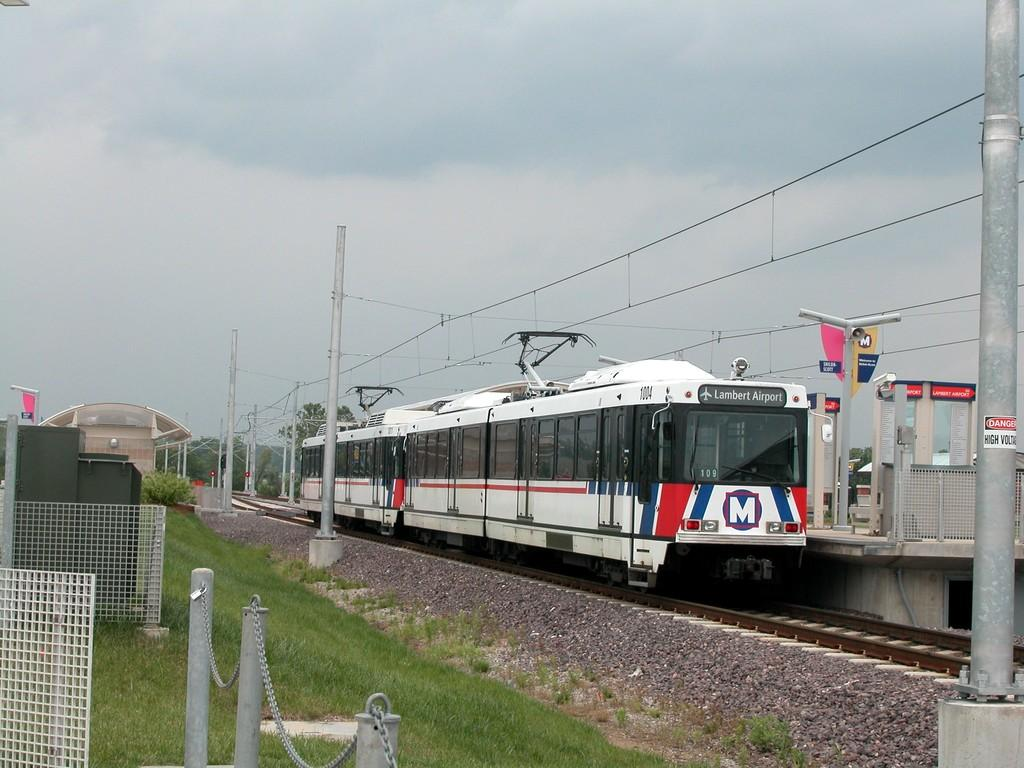What is the main subject of the image? The main subject of the image is a train. Where is the train located in the image? The train is on a train track. What can be seen in the background of the image? Electric poles and electric wires are visible in the image. What type of surface is present near the train? There is a mesh, grass, and stones in the image. How would you describe the weather in the image? The sky is cloudy in the image. Can you tell me how many times the river is mentioned in the image? There is no river present in the image, so it cannot be mentioned. What type of chain can be seen connecting the train to the electric poles in the image? There is no chain connecting the train to the electric poles in the image; the train is on a train track, and the electric wires are connected to the electric poles. 